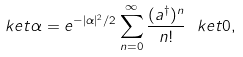Convert formula to latex. <formula><loc_0><loc_0><loc_500><loc_500>\ k e t { \alpha } = e ^ { - | \alpha | ^ { 2 } / 2 } \sum _ { n = 0 } ^ { \infty } \frac { ( a ^ { \dag } ) ^ { n } } { n ! } \ k e t { 0 } ,</formula> 